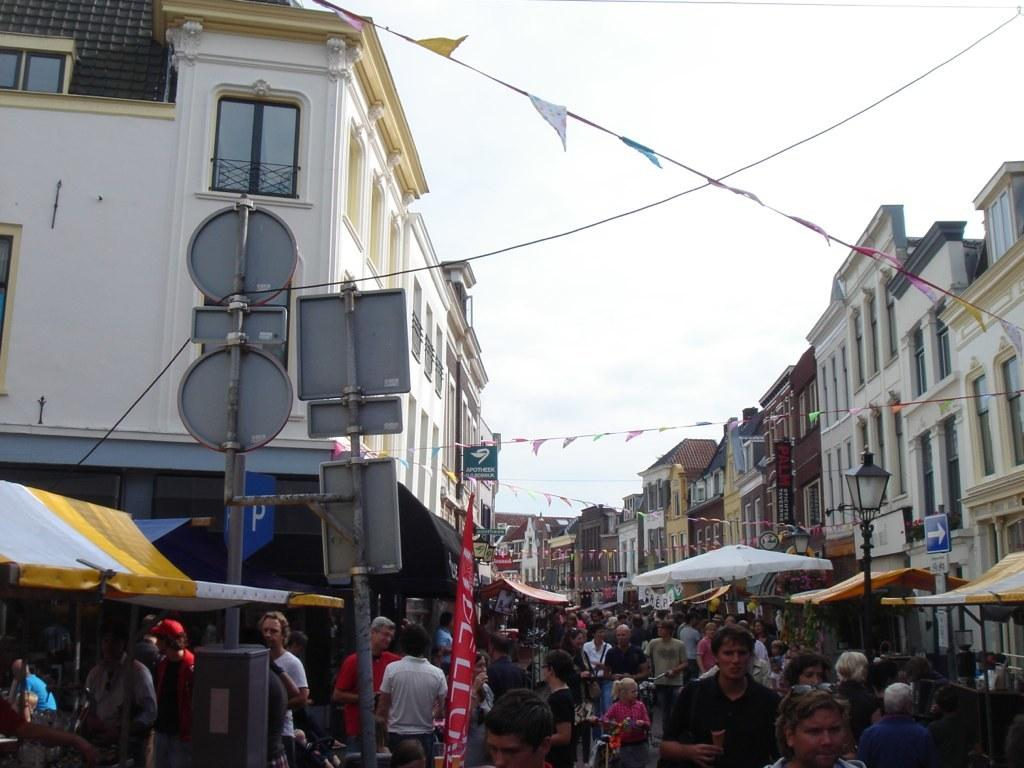What are the people in the image doing? There are many people walking on the road in the image. What can be seen on the sides of the road? Sign boards and light poles are visible in the image. What type of temporary structures can be seen in the image? Tents are visible in the image. What type of buildings can be seen in the image? Buildings are present in the image. What else is visible in the image besides the people and structures? Flags and wires are present in the image. What is visible in the background of the image? The sky is visible in the background of the image. How many health benefits can be seen on the parcel in the image? There is no parcel present in the image, and therefore no health benefits can be seen. Are there any bears visible in the image? There are no bears present in the image. 